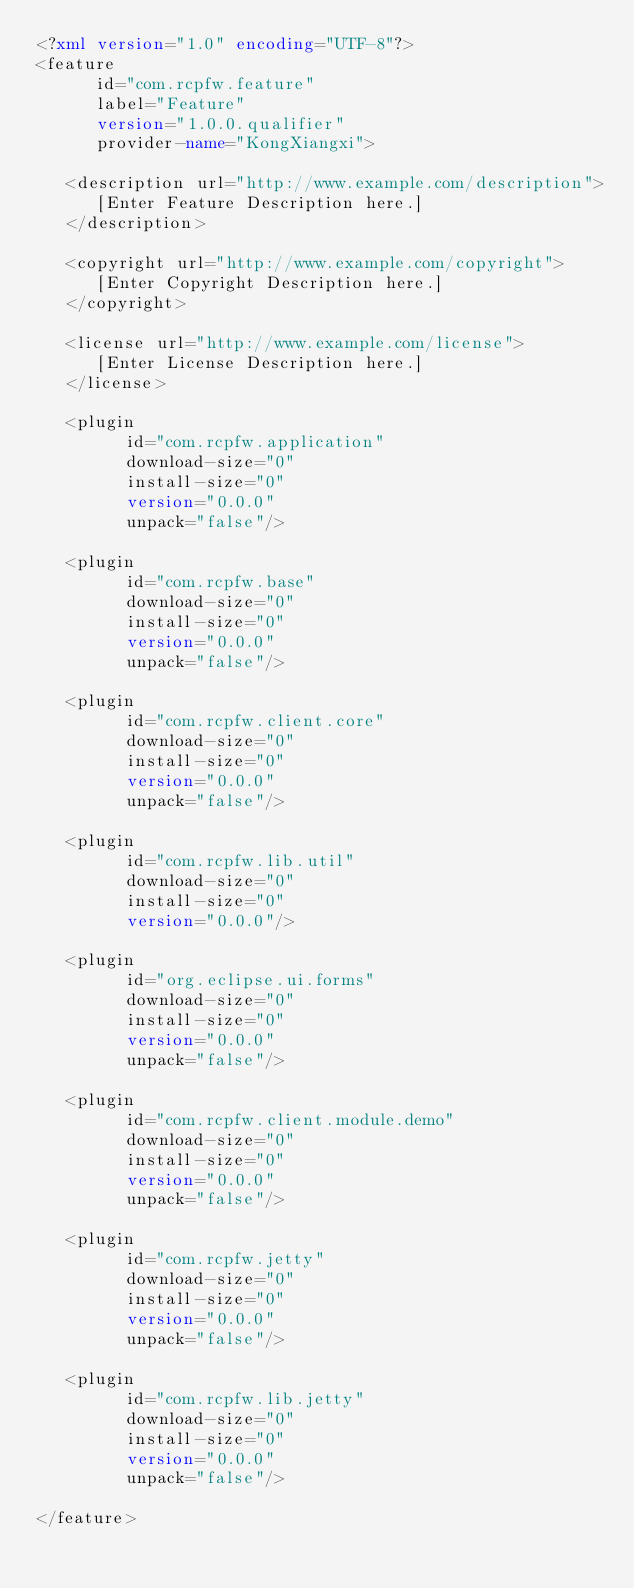Convert code to text. <code><loc_0><loc_0><loc_500><loc_500><_XML_><?xml version="1.0" encoding="UTF-8"?>
<feature
      id="com.rcpfw.feature"
      label="Feature"
      version="1.0.0.qualifier"
      provider-name="KongXiangxi">

   <description url="http://www.example.com/description">
      [Enter Feature Description here.]
   </description>

   <copyright url="http://www.example.com/copyright">
      [Enter Copyright Description here.]
   </copyright>

   <license url="http://www.example.com/license">
      [Enter License Description here.]
   </license>

   <plugin
         id="com.rcpfw.application"
         download-size="0"
         install-size="0"
         version="0.0.0"
         unpack="false"/>

   <plugin
         id="com.rcpfw.base"
         download-size="0"
         install-size="0"
         version="0.0.0"
         unpack="false"/>

   <plugin
         id="com.rcpfw.client.core"
         download-size="0"
         install-size="0"
         version="0.0.0"
         unpack="false"/>

   <plugin
         id="com.rcpfw.lib.util"
         download-size="0"
         install-size="0"
         version="0.0.0"/>

   <plugin
         id="org.eclipse.ui.forms"
         download-size="0"
         install-size="0"
         version="0.0.0"
         unpack="false"/>

   <plugin
         id="com.rcpfw.client.module.demo"
         download-size="0"
         install-size="0"
         version="0.0.0"
         unpack="false"/>

   <plugin
         id="com.rcpfw.jetty"
         download-size="0"
         install-size="0"
         version="0.0.0"
         unpack="false"/>

   <plugin
         id="com.rcpfw.lib.jetty"
         download-size="0"
         install-size="0"
         version="0.0.0"
         unpack="false"/>

</feature>
</code> 